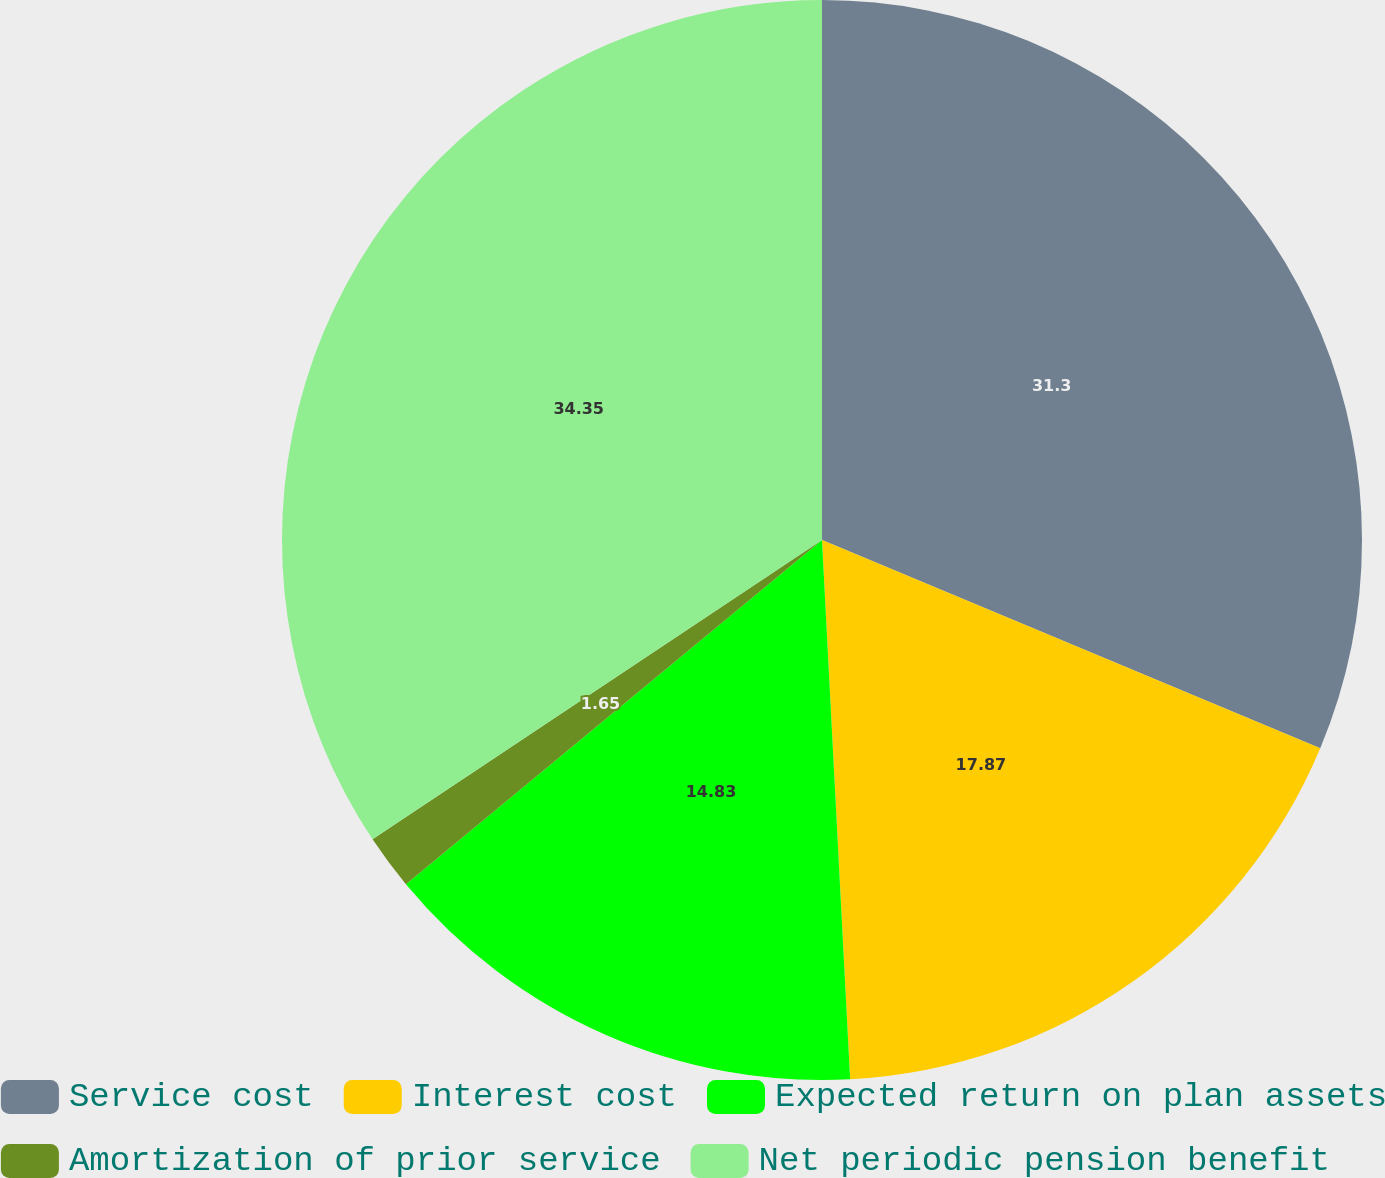Convert chart. <chart><loc_0><loc_0><loc_500><loc_500><pie_chart><fcel>Service cost<fcel>Interest cost<fcel>Expected return on plan assets<fcel>Amortization of prior service<fcel>Net periodic pension benefit<nl><fcel>31.3%<fcel>17.87%<fcel>14.83%<fcel>1.65%<fcel>34.35%<nl></chart> 